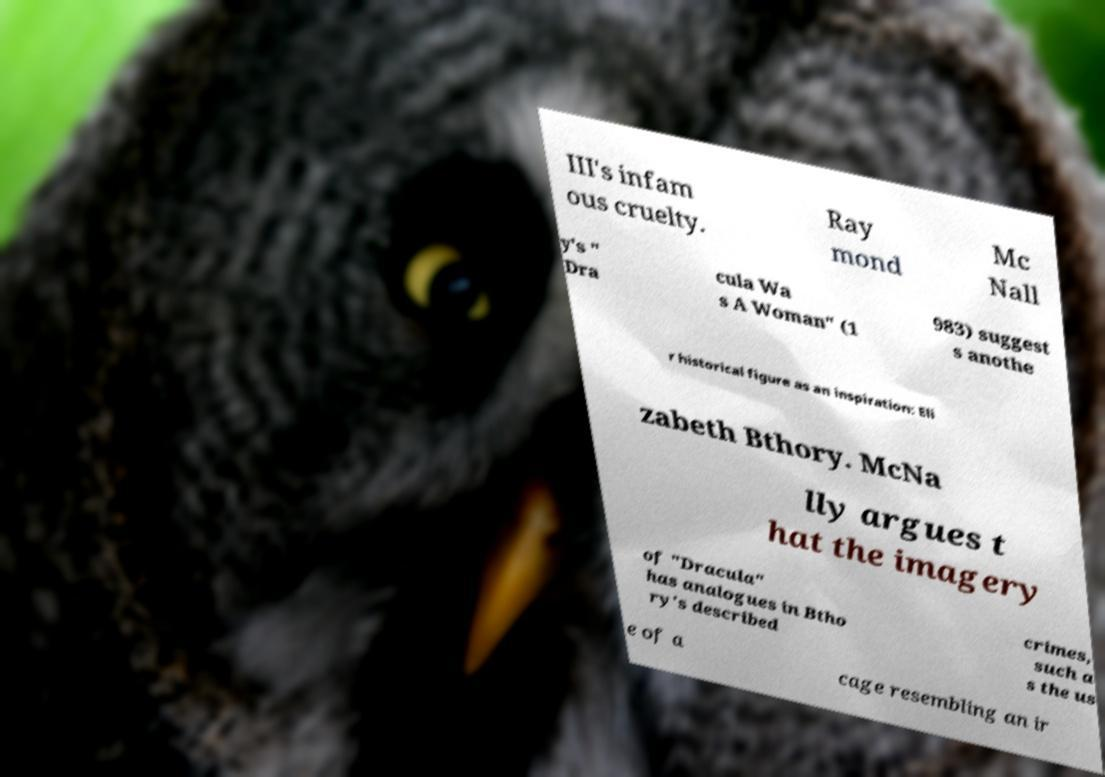Please identify and transcribe the text found in this image. III's infam ous cruelty. Ray mond Mc Nall y's " Dra cula Wa s A Woman" (1 983) suggest s anothe r historical figure as an inspiration: Eli zabeth Bthory. McNa lly argues t hat the imagery of "Dracula" has analogues in Btho ry's described crimes, such a s the us e of a cage resembling an ir 